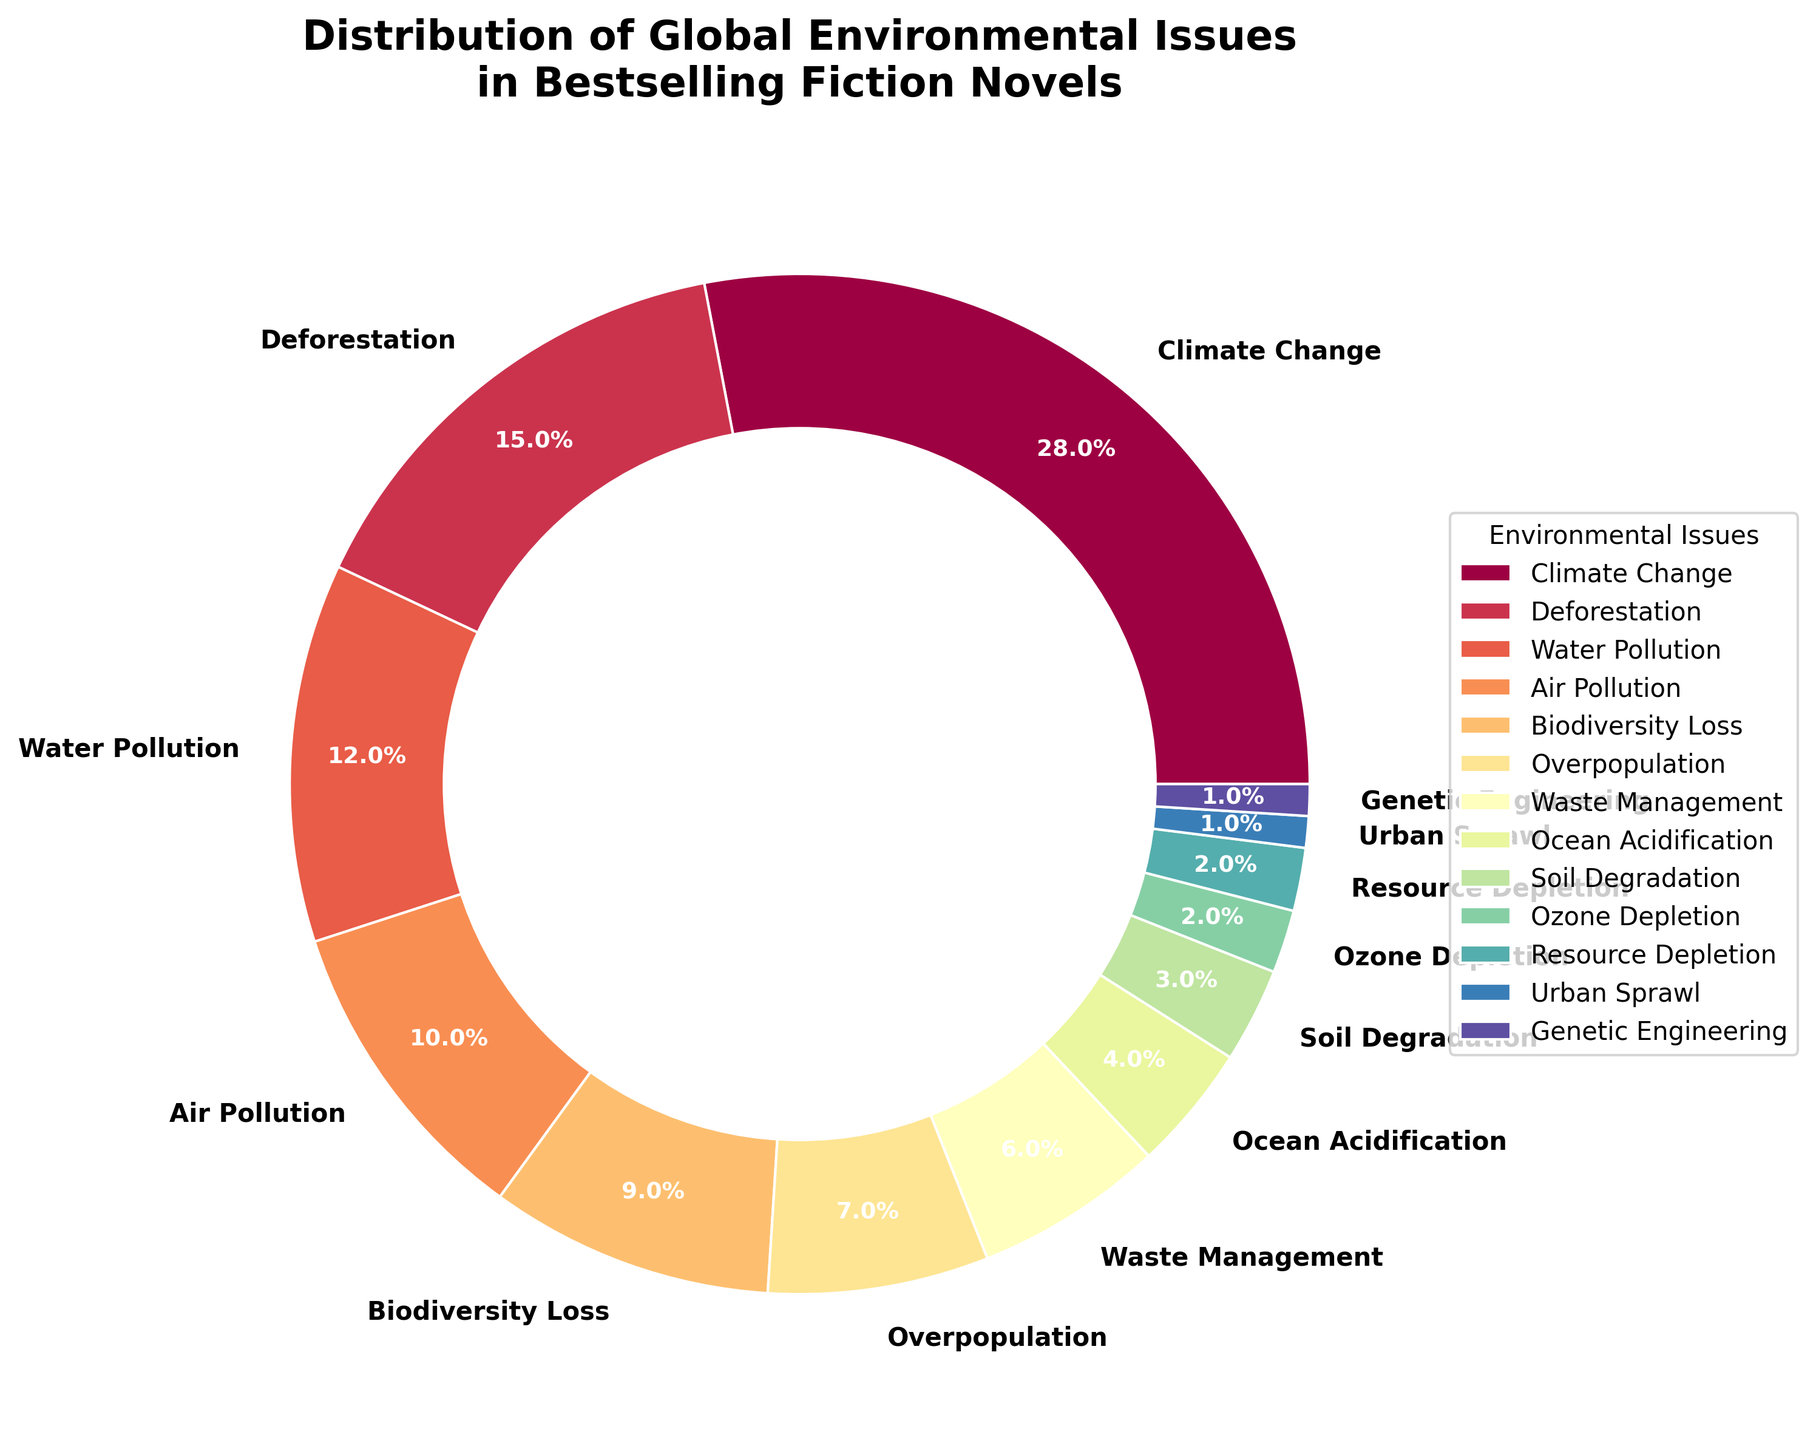What percentage of the novels address Climate Change and Deforestation combined? To find the combined percentage, add the percentages for Climate Change and Deforestation: 28% + 15% = 43%.
Answer: 43% Which environmental issue is addressed the least in bestselling fiction novels? Look for the smallest percentage listed in the chart. Both Urban Sprawl and Genetic Engineering are at 1%. So either can be the answer.
Answer: Urban Sprawl (or Genetic Engineering) How many more novels address Climate Change than Waste Management? Subtract the Waste Management percentage from the Climate Change percentage: 28% - 6% = 22%.
Answer: 22% Do more novels address Air Pollution or Water Pollution? Compare the percentages for Air Pollution (10%) and Water Pollution (12%). Water Pollution has a higher percentage.
Answer: Water Pollution What is the total percentage of novels addressing Biodiversity Loss, Overpopulation, and Ocean Acidification? Add the percentages for Biodiversity Loss, Overpopulation, and Ocean Acidification: 9% + 7% + 4% = 20%.
Answer: 20% How does the percentage of novels addressing Soil Degradation compare to those addressing Resource Depletion? Look at the percentages for Soil Degradation (3%) and Resource Depletion (2%). Soil Degradation is addressed 1% more than Resource Depletion.
Answer: Soil Degradation (1% more) Which issue has a higher percentage of novels addressing it: Waste Management or Overpopulation? Compare the percentages for Waste Management (6%) and Overpopulation (7%). Overpopulation has a higher percentage.
Answer: Overpopulation By how much does the percentage of novels addressing Climate Change exceed those addressing Air Pollution? Subtract the Air Pollution percentage from the Climate Change percentage: 28% - 10% = 18%.
Answer: 18% What is the combined percentage of novels addressing Air Pollution and Deforestation? To find the combined percentage, add the percentages for Air Pollution and Deforestation: 10% + 15% = 25%.
Answer: 25% How does the proportion of novels addressing Ocean Acidification compare to those addressing Ozone Depletion? Compare the percentages for Ocean Acidification (4%) and Ozone Depletion (2%). Ocean Acidification is addressed 2% more.
Answer: Ocean Acidification (2% more) 